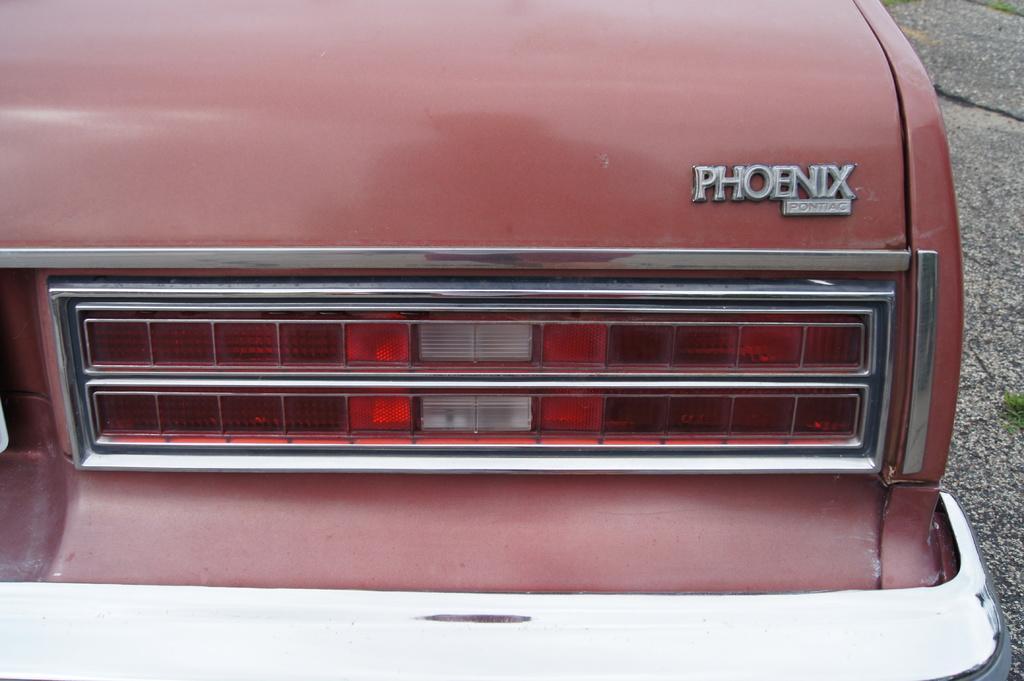Can you describe this image briefly? In this image I can see tail light of a pink colour vehicle. On the right side of the vehicle I can see something is written on it. 